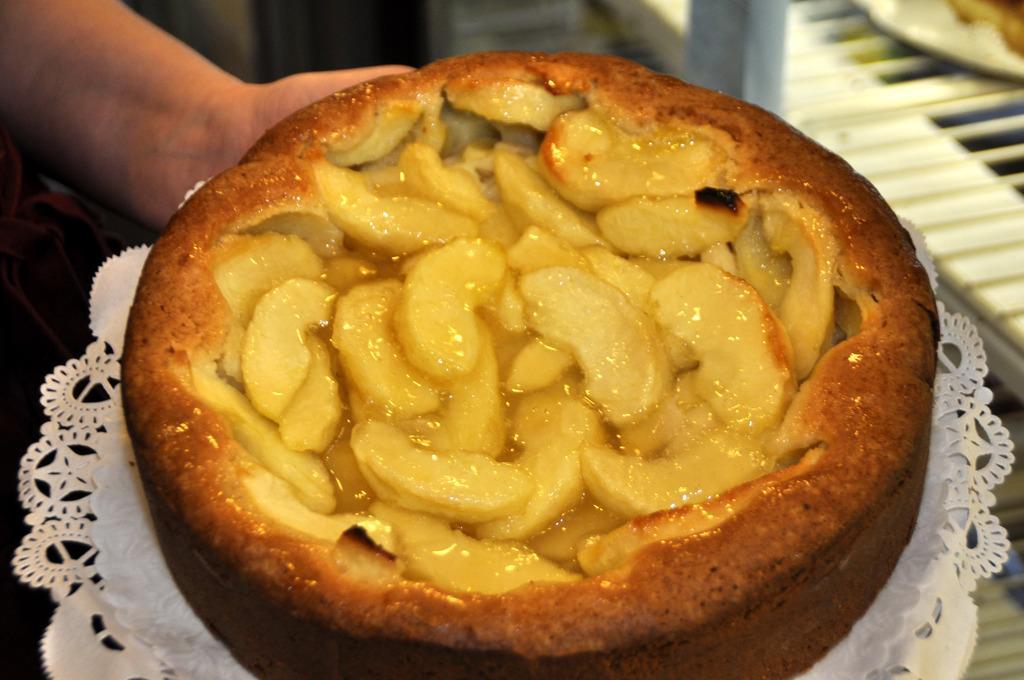In one or two sentences, can you explain what this image depicts? We can see plate with cake and cloth hold with hand. In the background it is blurry and we can see object on the platform. 